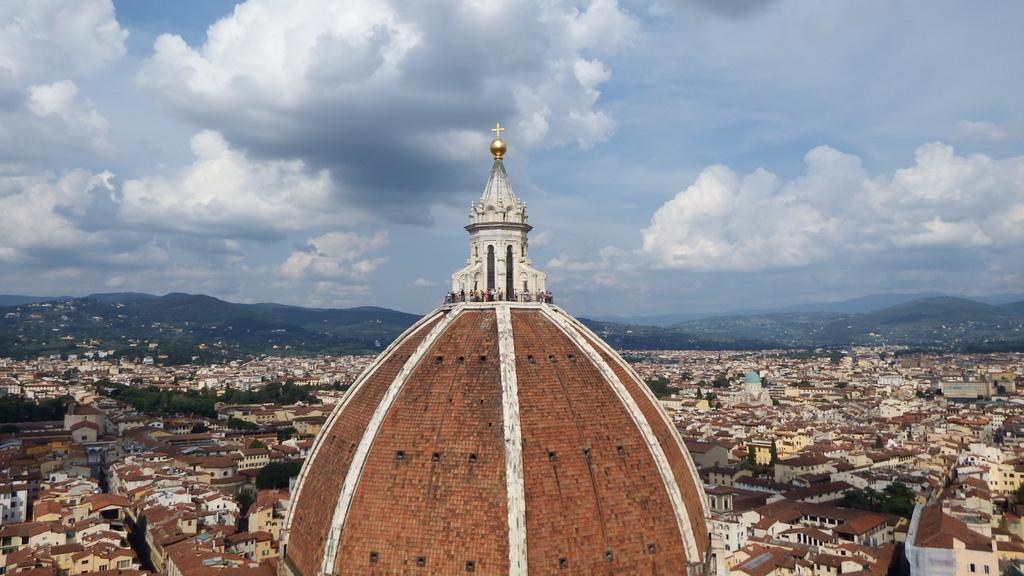Please provide a concise description of this image. In this image I can see the top of the building and few persons standing on it. In the background I can see few buildings, few trees, few mountains and the sky. 